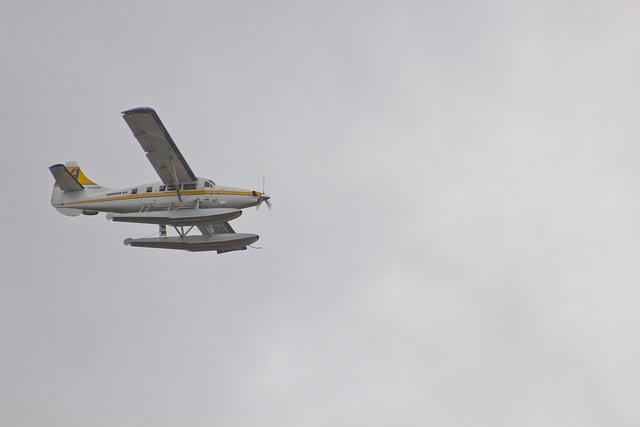What type of plane is this?
Short answer required. Propeller. Is there a knife?
Concise answer only. No. Can the plane land on water?
Be succinct. Yes. Is it sunny out?
Answer briefly. No. What color is the stripe on the plane?
Be succinct. Yellow. Is this a vintage war plane?
Quick response, please. No. Is this a real plane?
Concise answer only. Yes. 